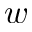Convert formula to latex. <formula><loc_0><loc_0><loc_500><loc_500>w</formula> 